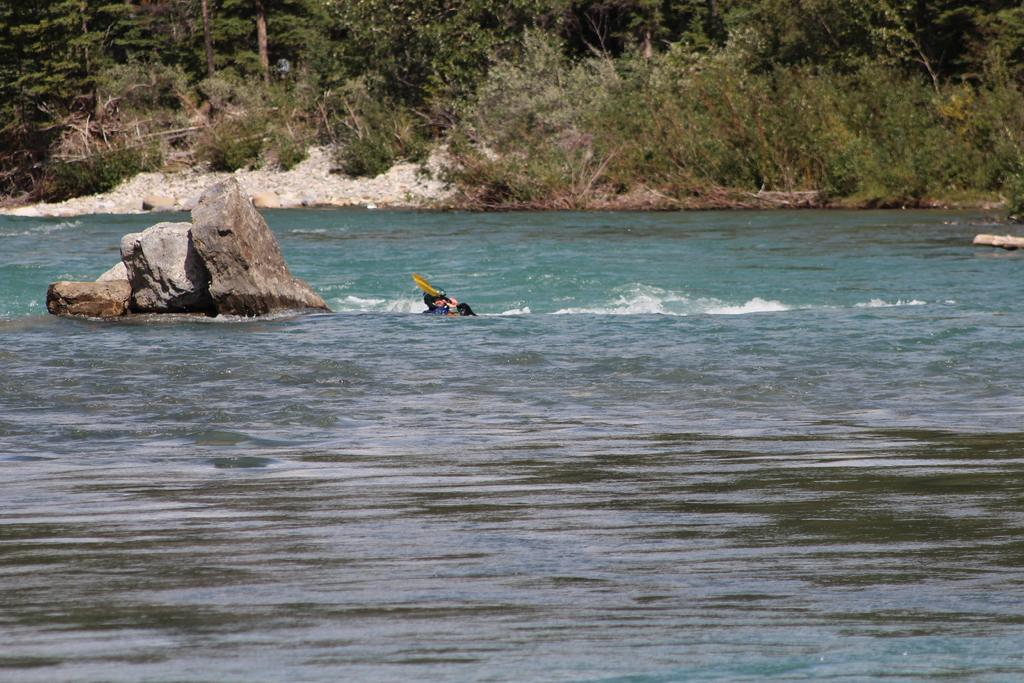What is the man in the image doing? The man is swimming in the water. What can be seen in the water besides the man? There is a big rock in the water. What type of natural environment is visible in the background? There are trees visible in the background. Where can the fairies be found in the image? There are no fairies present in the image. What type of answer can be seen written on the seashore in the image? There is no answer or writing visible on the seashore in the image. 